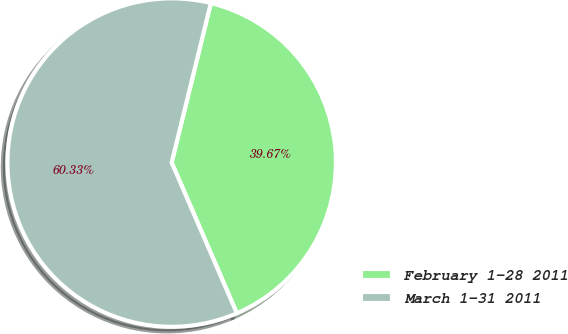<chart> <loc_0><loc_0><loc_500><loc_500><pie_chart><fcel>February 1-28 2011<fcel>March 1-31 2011<nl><fcel>39.67%<fcel>60.33%<nl></chart> 